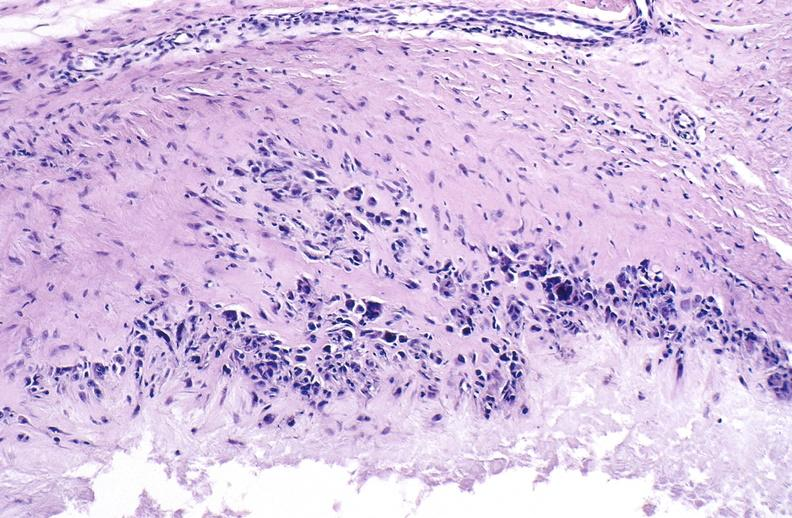what does this image show?
Answer the question using a single word or phrase. Gout 